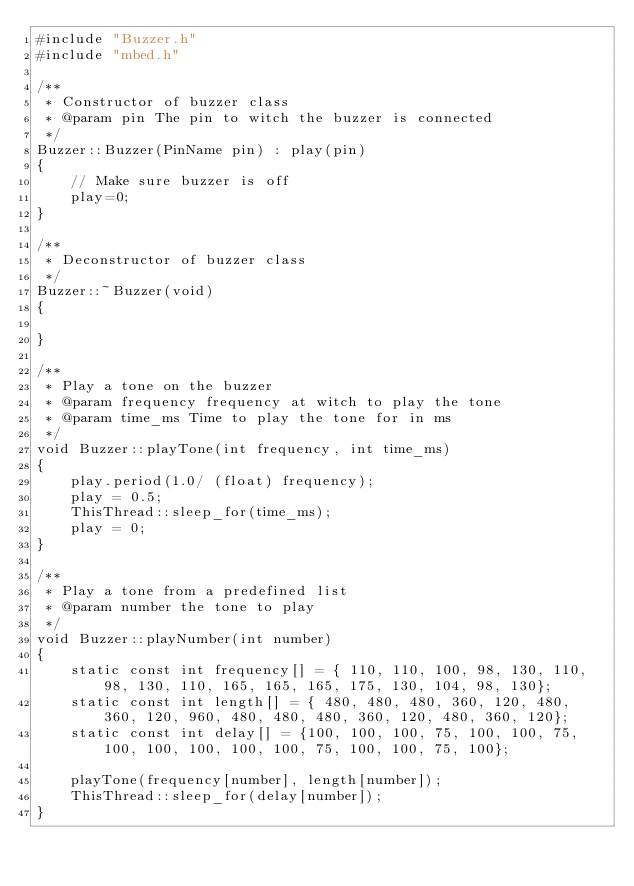<code> <loc_0><loc_0><loc_500><loc_500><_C++_>#include "Buzzer.h"
#include "mbed.h"

/**
 * Constructor of buzzer class
 * @param pin The pin to witch the buzzer is connected
 */
Buzzer::Buzzer(PinName pin) : play(pin)
{ 
    // Make sure buzzer is off
    play=0;
}

/**
 * Deconstructor of buzzer class
 */
Buzzer::~Buzzer(void)
{

}

/**
 * Play a tone on the buzzer
 * @param frequency frequency at witch to play the tone
 * @param time_ms Time to play the tone for in ms
 */
void Buzzer::playTone(int frequency, int time_ms)
{
    play.period(1.0/ (float) frequency);
    play = 0.5;
    ThisThread::sleep_for(time_ms);
    play = 0;
}

/**
 * Play a tone from a predefined list
 * @param number the tone to play
 */
void Buzzer::playNumber(int number) 
{
    static const int frequency[] = { 110, 110, 100, 98, 130, 110, 98, 130, 110, 165, 165, 165, 175, 130, 104, 98, 130};
    static const int length[] = { 480, 480, 480, 360, 120, 480, 360, 120, 960, 480, 480, 480, 360, 120, 480, 360, 120};
    static const int delay[] = {100, 100, 100, 75, 100, 100, 75, 100, 100, 100, 100, 100, 75, 100, 100, 75, 100};

    playTone(frequency[number], length[number]);
    ThisThread::sleep_for(delay[number]);
}</code> 